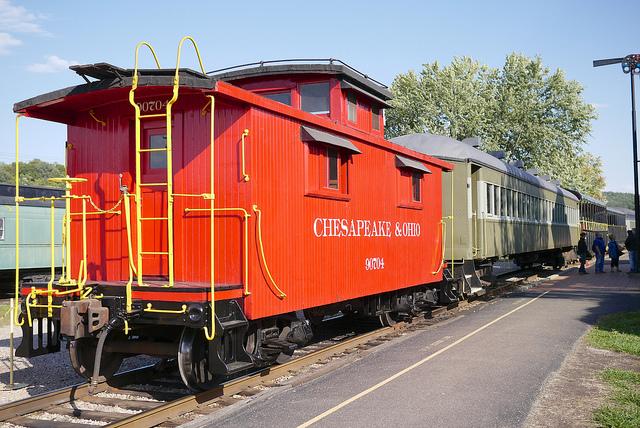Is this a passenger  train?
Give a very brief answer. Yes. What train car is red?
Concise answer only. Caboose. How many people are shown?
Give a very brief answer. 4. 